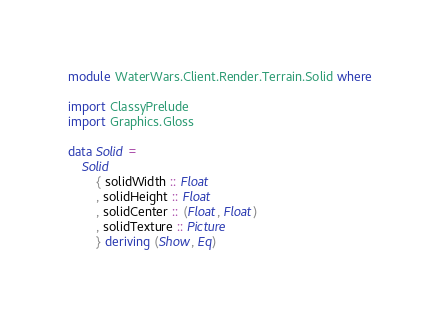Convert code to text. <code><loc_0><loc_0><loc_500><loc_500><_Haskell_>module WaterWars.Client.Render.Terrain.Solid where

import ClassyPrelude
import Graphics.Gloss

data Solid =
    Solid
        { solidWidth :: Float
        , solidHeight :: Float
        , solidCenter :: (Float, Float)
        , solidTexture :: Picture
        } deriving (Show, Eq)</code> 